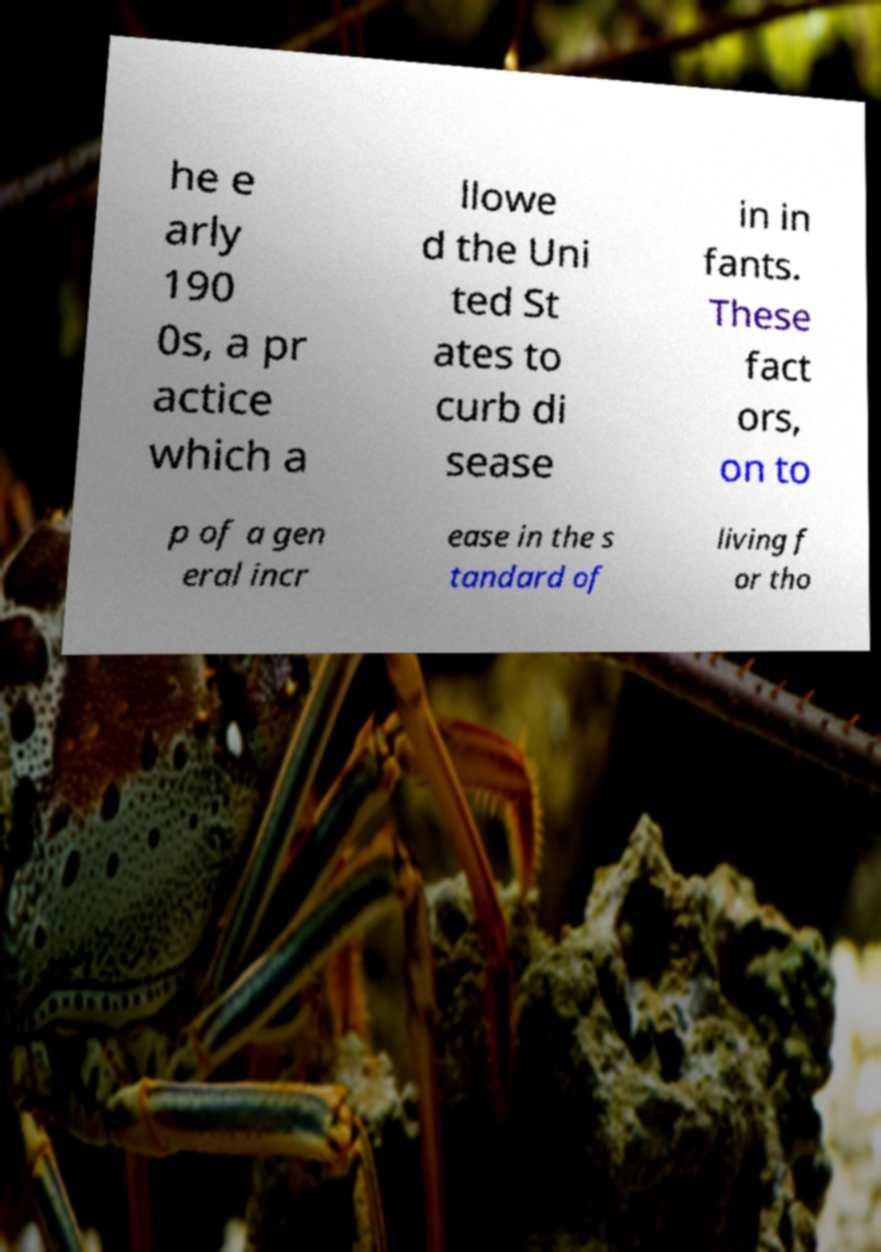What messages or text are displayed in this image? I need them in a readable, typed format. he e arly 190 0s, a pr actice which a llowe d the Uni ted St ates to curb di sease in in fants. These fact ors, on to p of a gen eral incr ease in the s tandard of living f or tho 